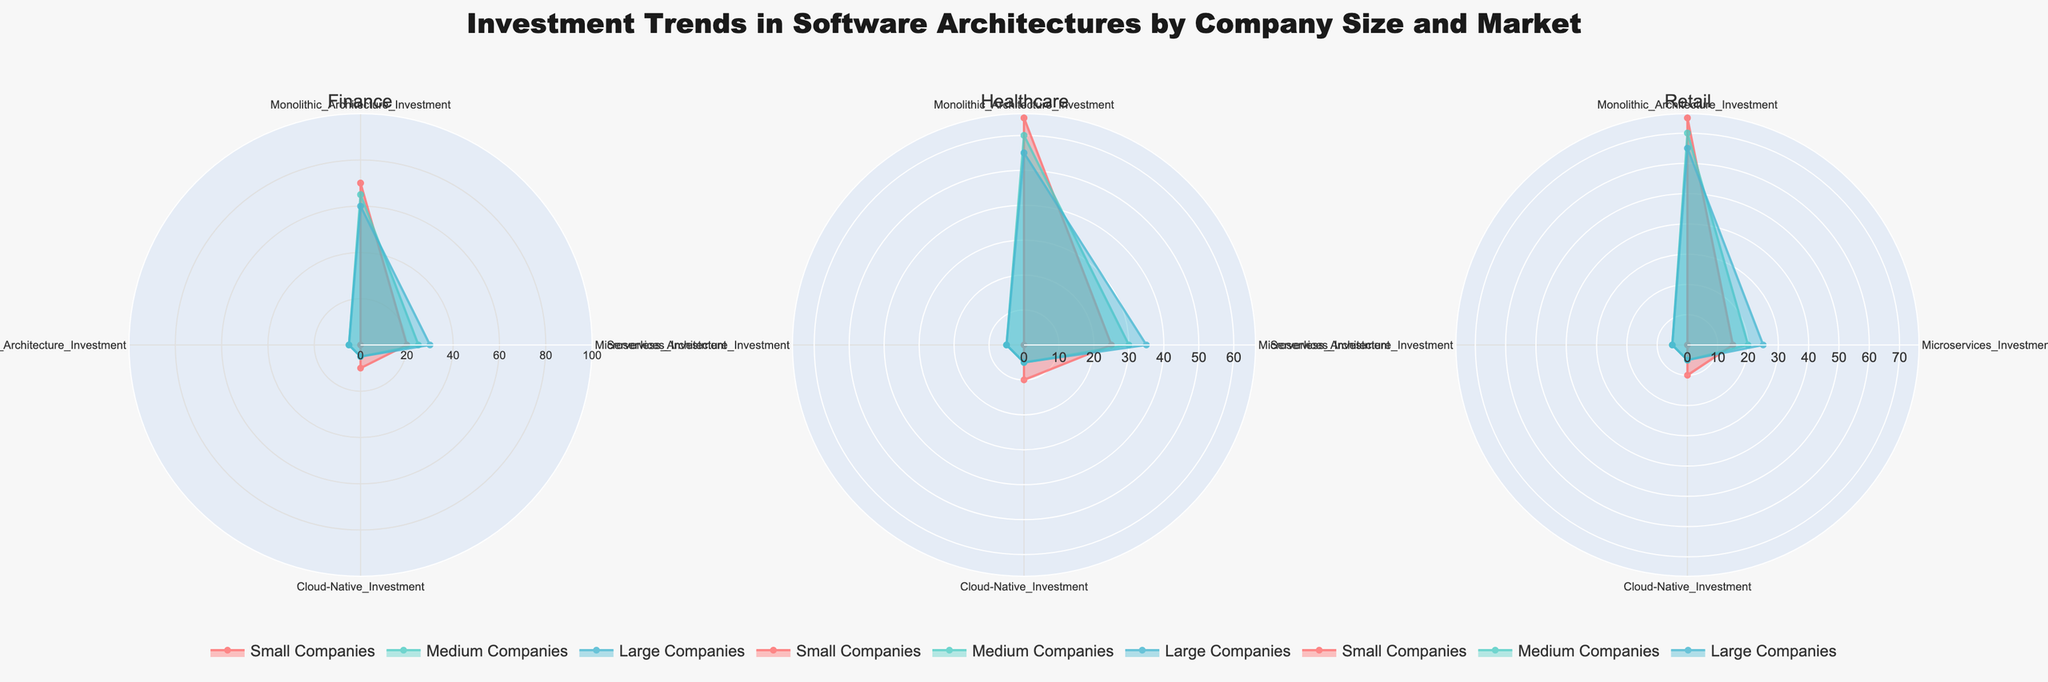What are the four types of architecture investments shown in the figure? The radar charts compare investments in Monolithic Architecture, Microservices, Cloud-Native, and Serverless across different company sizes and markets. These architectural styles are shown as the categories in the radar plot.
Answer: Monolithic Architecture, Microservices, Cloud-Native, Serverless Which company size has the highest investment in Monolithic Architecture in the Finance market? By analyzing the respective radar chart for the Finance market, the red line representing Small companies reaches the highest value for Monolithic Architecture compared to Medium and Large companies.
Answer: Small How does the investment in Microservices by Medium companies compare across the three markets? By visually comparing the segments representing Medium companies in each of the three radar charts, Medium companies have a Microservices investment of 25% in Finance, 30% in Healthcare, and 20% in Retail.
Answer: Finance: 25%, Healthcare: 30%, Retail: 20% What is the average investment in Cloud-Native Architecture across all company sizes in the Retail market? The investments in Cloud-Native Architecture for Small, Medium, and Large companies in Retail are 10%, 5%, and 5%, respectively. The average is calculated as (10 + 5 + 5) / 3.
Answer: 6.67% Which market shows the lowest investment in Serverless Architecture for Small companies? By comparing the segments for Small companies in all markets, the smallest investment in Serverless Architecture is in the Finance, Healthcare, and Retail markets, all showing 0%.
Answer: All markets For Large companies, what is the difference in investment between Monolithic Architecture and Microservices in the Healthcare market? In Healthcare, Large companies invest 55% in Monolithic Architecture and 35% in Microservices. The difference is calculated by subtracting 35 from 55.
Answer: 20% In the Healthcare market, which company size invests the most in Microservices? By examining the respective radar chart for Healthcare, the subset representing Large companies reaches the highest investment in Microservices, followed by Medium and Small companies.
Answer: Large What is the total investment percentage for Serverless Architecture across all markets and company sizes? Serverless investments are: Small Finance 0%, Small Healthcare 0%, Small Retail 0%, Medium Finance 5%, Medium Healthcare 5%, Medium Retail 5%, Large Finance 5%, Large Healthcare 5%, Large Retail 5%. Summing these gives 0 + 0 + 0 + 5 + 5 + 5 + 5 + 5 + 5.
Answer: 30% Which company size shows the most significant variation in Monolithic Architecture investment across different markets? Comparing the radar charts for Monolithic Architecture, Small companies show investments of 70%, 65%, and 75% in Finance, Healthcare, and Retail respectively. The variation is calculated as the range (75 - 65).
Answer: Small How does the investment in Cloud-Native by Large companies in Retail compare to their investment in the same architecture in Healthcare? By looking at the plots, the investment in Cloud-Native Architecture by Large companies in both Retail and Healthcare is 5%. Therefore, there's no difference.
Answer: Equal 